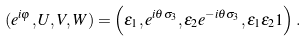Convert formula to latex. <formula><loc_0><loc_0><loc_500><loc_500>( e ^ { i \varphi } , U , V , W ) = \left ( \varepsilon _ { 1 } , e ^ { i \theta \sigma _ { 3 } } , \varepsilon _ { 2 } e ^ { - i \theta \sigma _ { 3 } } , \varepsilon _ { 1 } \varepsilon _ { 2 } 1 \right ) .</formula> 